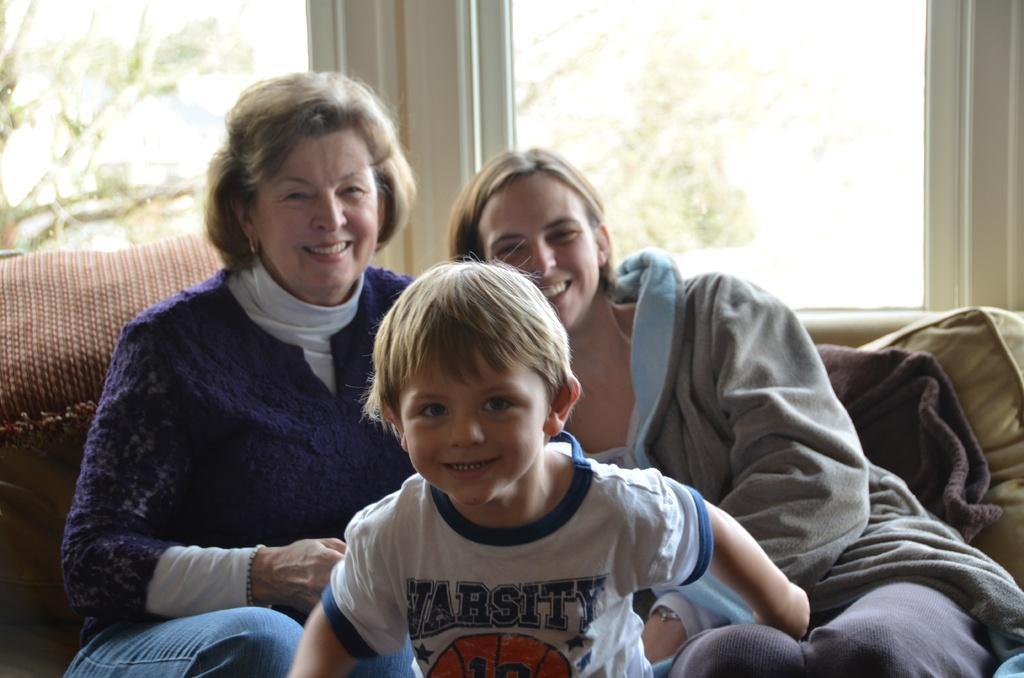How would you summarize this image in a sentence or two? In the picture we can see two women and a boy are sitting on the sofa and they are smiling and behind them, we can see a wall with two glass windows in it and from the glass we can see some plants outside which are not clearly visible. 